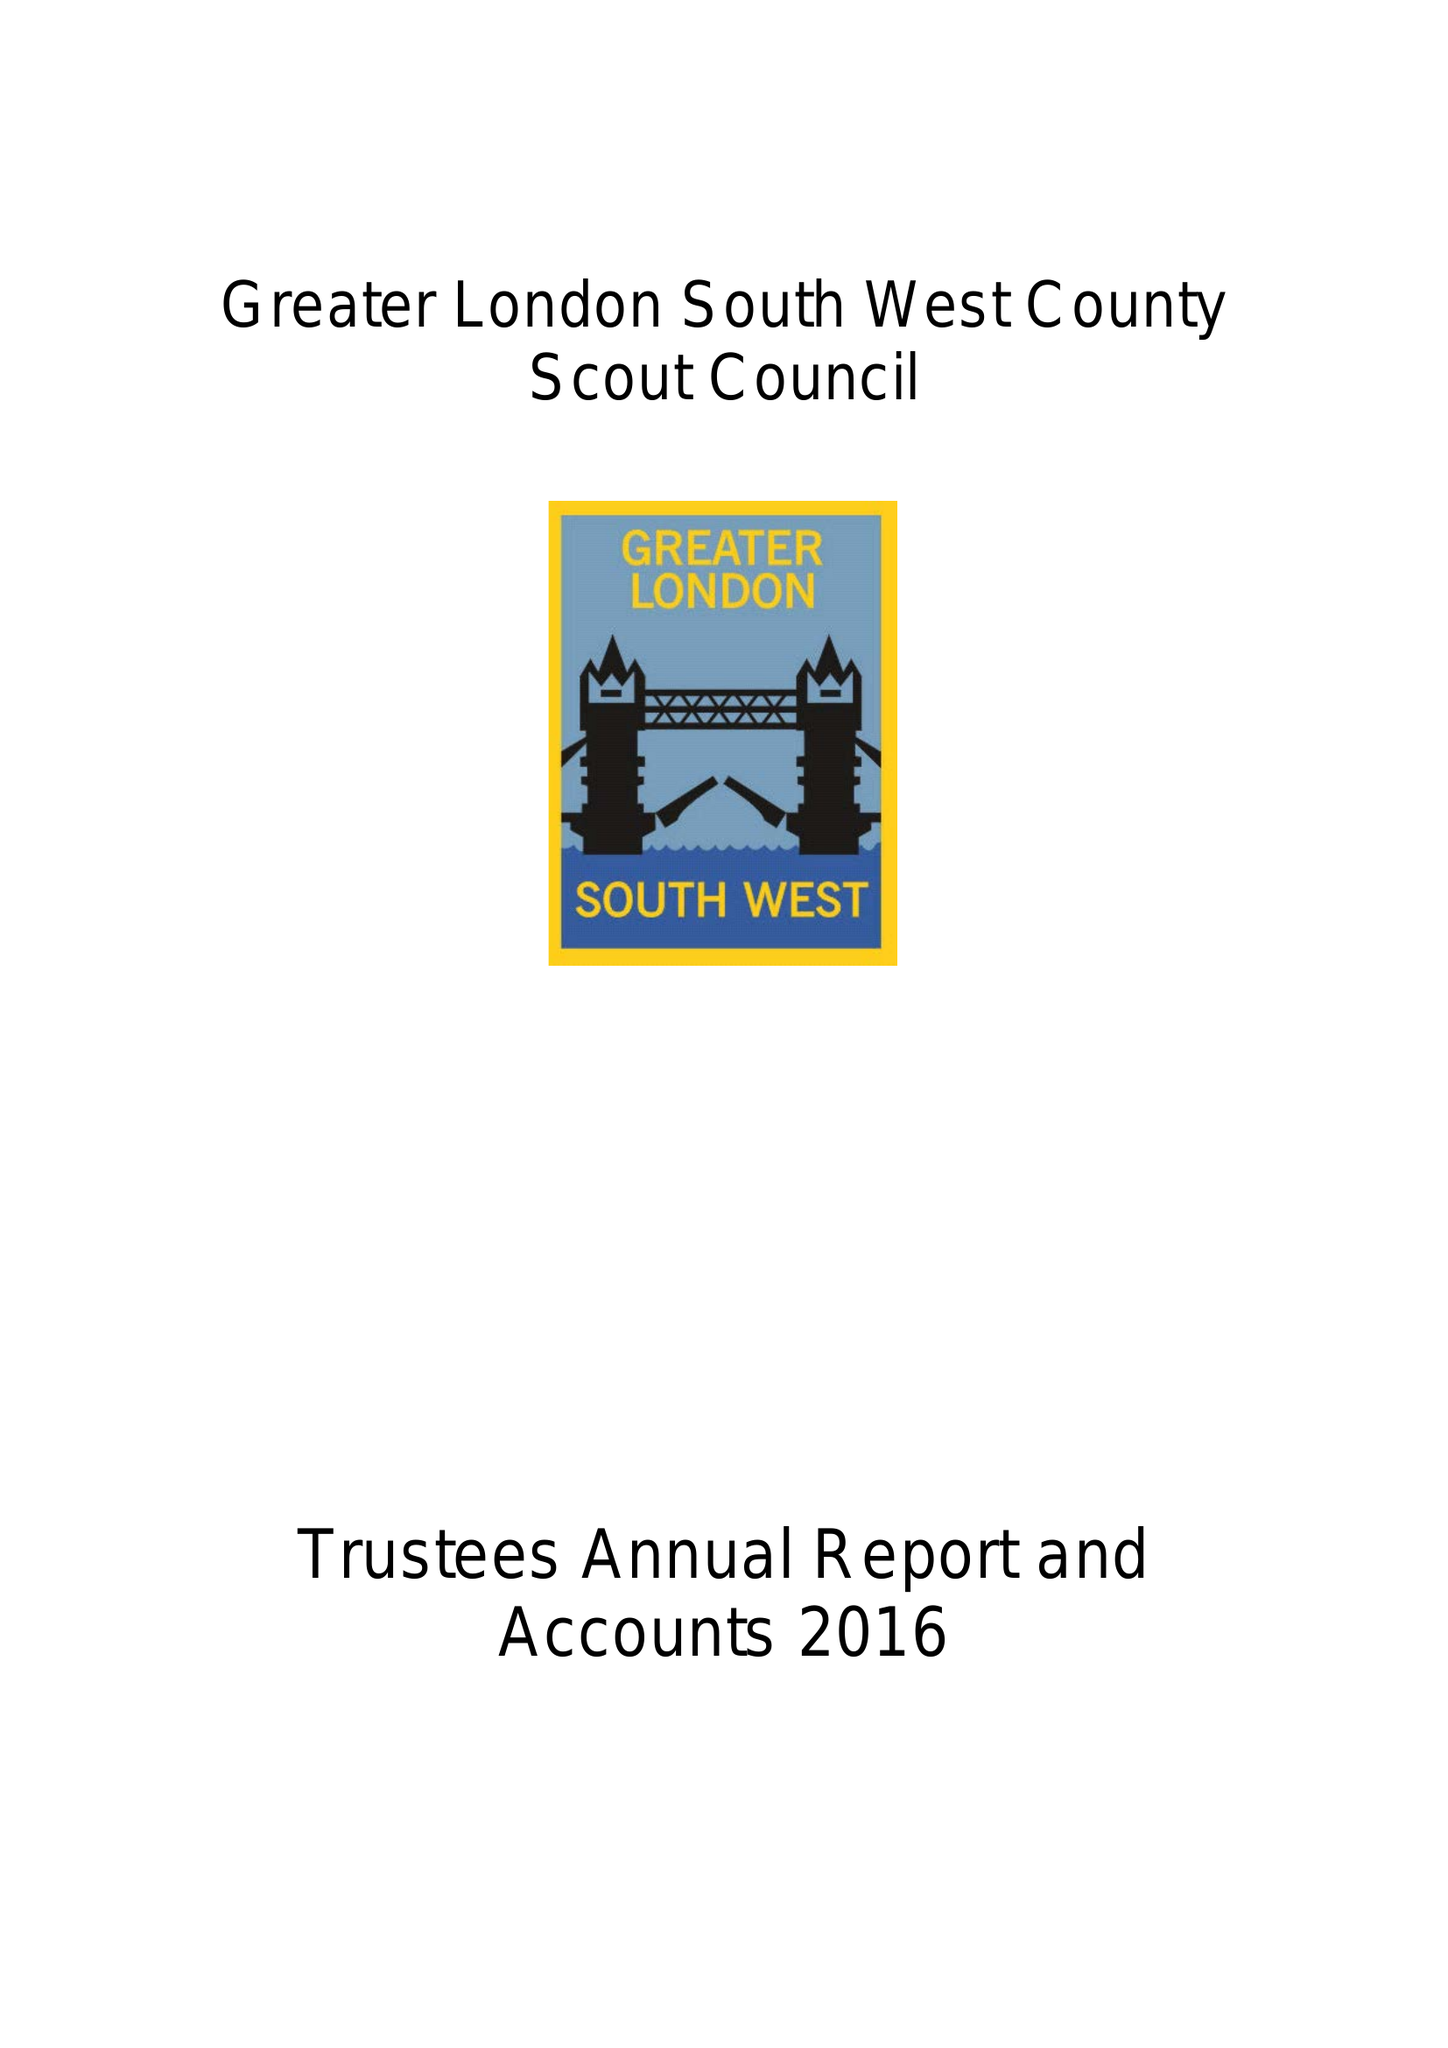What is the value for the address__post_town?
Answer the question using a single word or phrase. WORCESTER PARK 